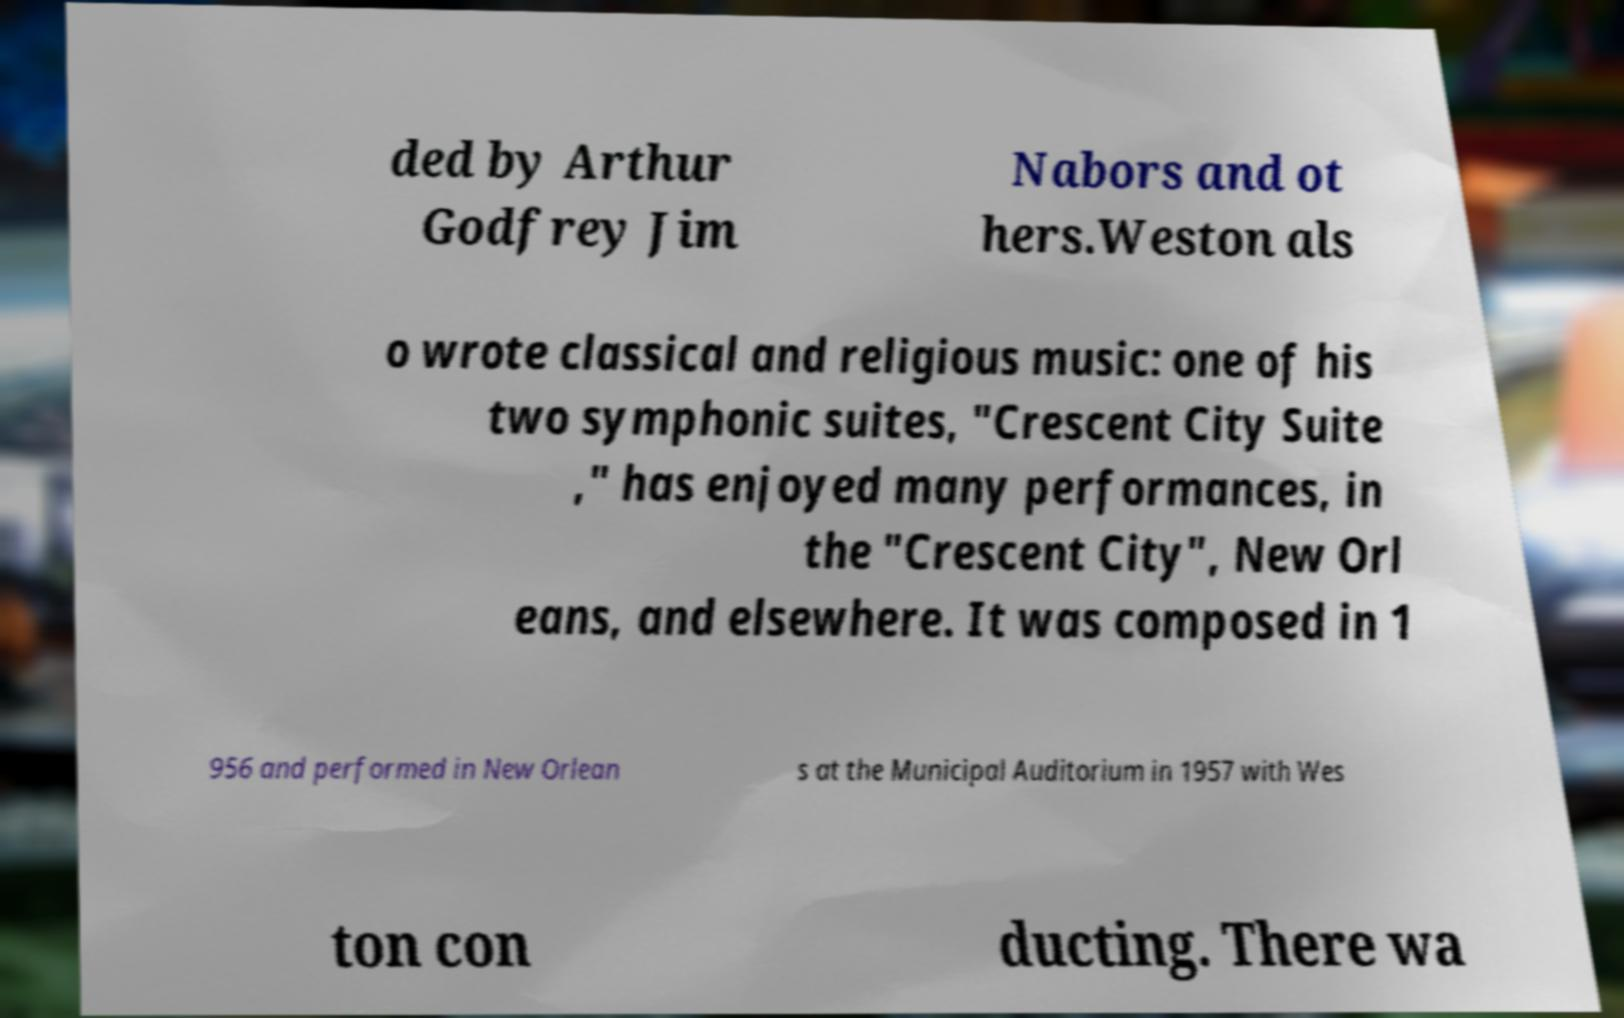For documentation purposes, I need the text within this image transcribed. Could you provide that? ded by Arthur Godfrey Jim Nabors and ot hers.Weston als o wrote classical and religious music: one of his two symphonic suites, "Crescent City Suite ," has enjoyed many performances, in the "Crescent City", New Orl eans, and elsewhere. It was composed in 1 956 and performed in New Orlean s at the Municipal Auditorium in 1957 with Wes ton con ducting. There wa 